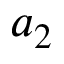Convert formula to latex. <formula><loc_0><loc_0><loc_500><loc_500>a _ { 2 }</formula> 